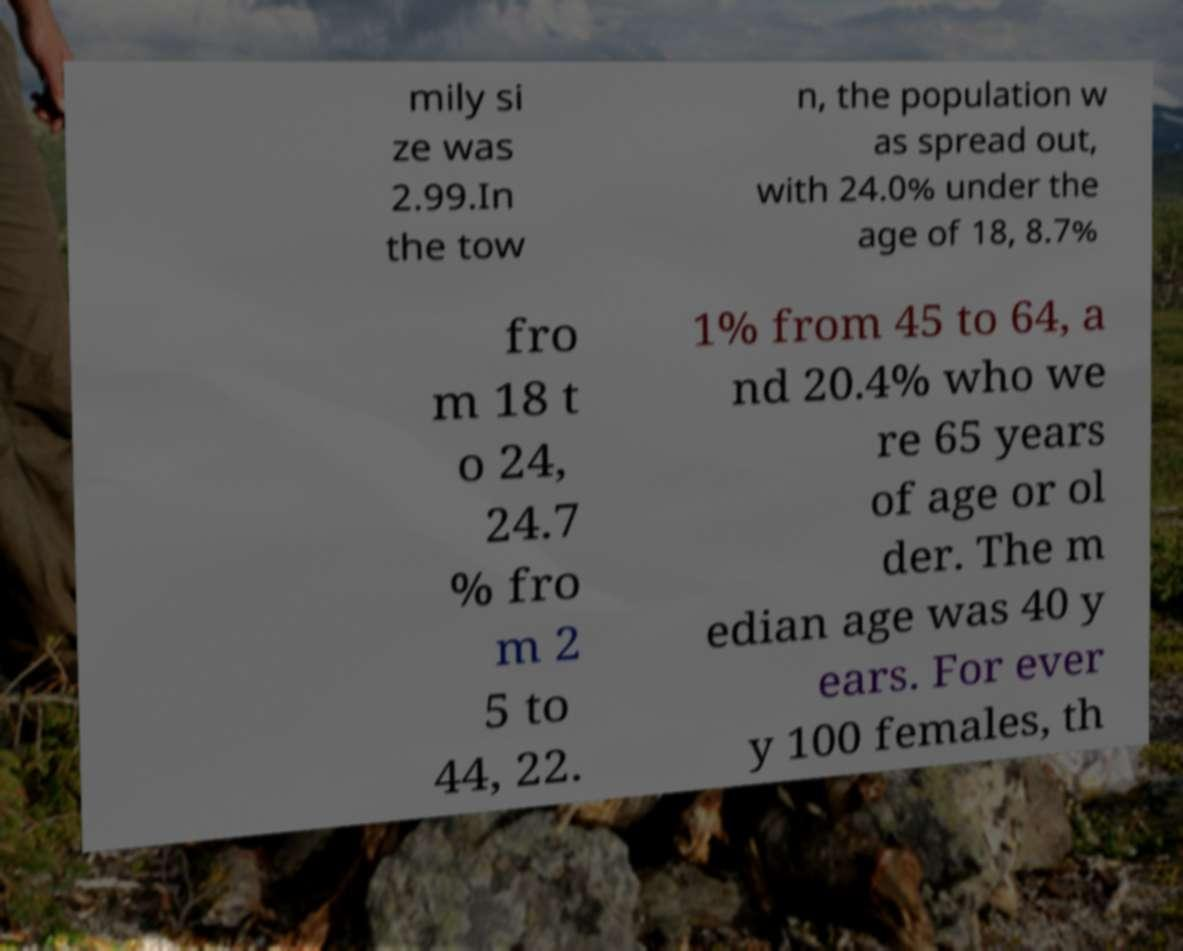Can you read and provide the text displayed in the image?This photo seems to have some interesting text. Can you extract and type it out for me? mily si ze was 2.99.In the tow n, the population w as spread out, with 24.0% under the age of 18, 8.7% fro m 18 t o 24, 24.7 % fro m 2 5 to 44, 22. 1% from 45 to 64, a nd 20.4% who we re 65 years of age or ol der. The m edian age was 40 y ears. For ever y 100 females, th 